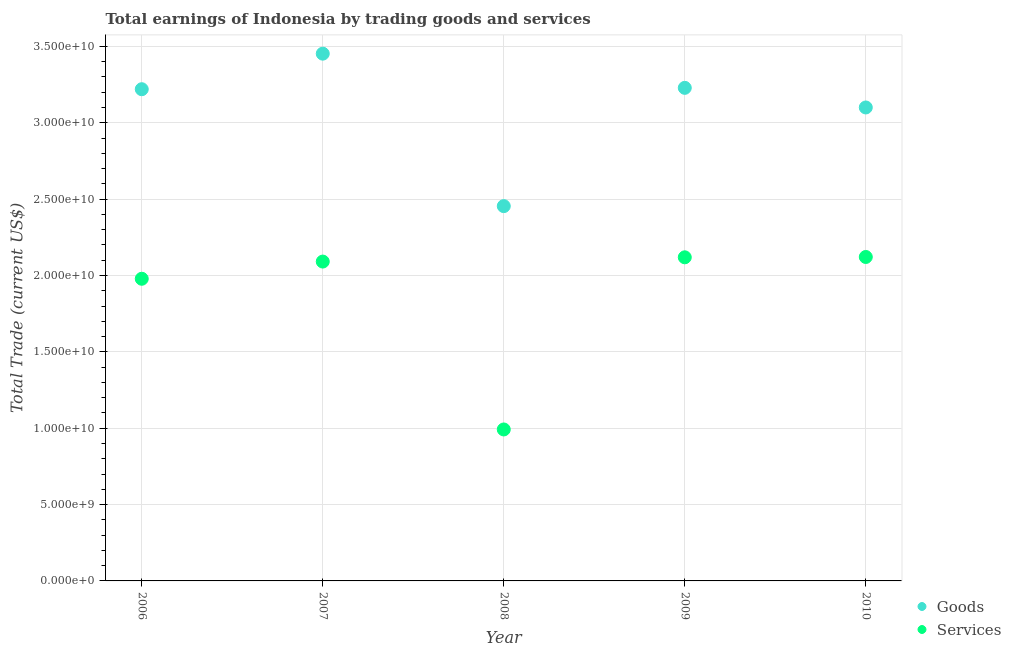How many different coloured dotlines are there?
Provide a short and direct response. 2. What is the amount earned by trading services in 2008?
Offer a very short reply. 9.92e+09. Across all years, what is the maximum amount earned by trading goods?
Give a very brief answer. 3.45e+1. Across all years, what is the minimum amount earned by trading goods?
Your answer should be very brief. 2.45e+1. In which year was the amount earned by trading services maximum?
Your answer should be very brief. 2010. In which year was the amount earned by trading services minimum?
Give a very brief answer. 2008. What is the total amount earned by trading goods in the graph?
Your response must be concise. 1.55e+11. What is the difference between the amount earned by trading goods in 2006 and that in 2008?
Your answer should be very brief. 7.66e+09. What is the difference between the amount earned by trading services in 2010 and the amount earned by trading goods in 2009?
Provide a succinct answer. -1.11e+1. What is the average amount earned by trading goods per year?
Your answer should be very brief. 3.09e+1. In the year 2009, what is the difference between the amount earned by trading services and amount earned by trading goods?
Provide a succinct answer. -1.11e+1. In how many years, is the amount earned by trading services greater than 31000000000 US$?
Provide a succinct answer. 0. What is the ratio of the amount earned by trading services in 2006 to that in 2008?
Provide a short and direct response. 2. What is the difference between the highest and the second highest amount earned by trading services?
Provide a succinct answer. 2.11e+07. What is the difference between the highest and the lowest amount earned by trading goods?
Ensure brevity in your answer.  9.98e+09. Does the amount earned by trading goods monotonically increase over the years?
Provide a short and direct response. No. Is the amount earned by trading goods strictly less than the amount earned by trading services over the years?
Make the answer very short. No. How many years are there in the graph?
Your answer should be compact. 5. Does the graph contain any zero values?
Provide a short and direct response. No. Does the graph contain grids?
Your answer should be very brief. Yes. How many legend labels are there?
Your response must be concise. 2. How are the legend labels stacked?
Provide a succinct answer. Vertical. What is the title of the graph?
Ensure brevity in your answer.  Total earnings of Indonesia by trading goods and services. Does "Forest" appear as one of the legend labels in the graph?
Your answer should be very brief. No. What is the label or title of the X-axis?
Give a very brief answer. Year. What is the label or title of the Y-axis?
Offer a terse response. Total Trade (current US$). What is the Total Trade (current US$) in Goods in 2006?
Make the answer very short. 3.22e+1. What is the Total Trade (current US$) of Services in 2006?
Your answer should be compact. 1.98e+1. What is the Total Trade (current US$) of Goods in 2007?
Offer a very short reply. 3.45e+1. What is the Total Trade (current US$) in Services in 2007?
Your response must be concise. 2.09e+1. What is the Total Trade (current US$) of Goods in 2008?
Provide a short and direct response. 2.45e+1. What is the Total Trade (current US$) of Services in 2008?
Ensure brevity in your answer.  9.92e+09. What is the Total Trade (current US$) of Goods in 2009?
Make the answer very short. 3.23e+1. What is the Total Trade (current US$) of Services in 2009?
Your response must be concise. 2.12e+1. What is the Total Trade (current US$) of Goods in 2010?
Your answer should be compact. 3.10e+1. What is the Total Trade (current US$) of Services in 2010?
Ensure brevity in your answer.  2.12e+1. Across all years, what is the maximum Total Trade (current US$) in Goods?
Ensure brevity in your answer.  3.45e+1. Across all years, what is the maximum Total Trade (current US$) in Services?
Make the answer very short. 2.12e+1. Across all years, what is the minimum Total Trade (current US$) in Goods?
Give a very brief answer. 2.45e+1. Across all years, what is the minimum Total Trade (current US$) in Services?
Give a very brief answer. 9.92e+09. What is the total Total Trade (current US$) in Goods in the graph?
Keep it short and to the point. 1.55e+11. What is the total Total Trade (current US$) of Services in the graph?
Provide a succinct answer. 9.30e+1. What is the difference between the Total Trade (current US$) of Goods in 2006 and that in 2007?
Offer a very short reply. -2.33e+09. What is the difference between the Total Trade (current US$) of Services in 2006 and that in 2007?
Provide a succinct answer. -1.13e+09. What is the difference between the Total Trade (current US$) in Goods in 2006 and that in 2008?
Provide a succinct answer. 7.66e+09. What is the difference between the Total Trade (current US$) in Services in 2006 and that in 2008?
Keep it short and to the point. 9.87e+09. What is the difference between the Total Trade (current US$) of Goods in 2006 and that in 2009?
Provide a short and direct response. -8.96e+07. What is the difference between the Total Trade (current US$) in Services in 2006 and that in 2009?
Give a very brief answer. -1.41e+09. What is the difference between the Total Trade (current US$) of Goods in 2006 and that in 2010?
Provide a short and direct response. 1.20e+09. What is the difference between the Total Trade (current US$) in Services in 2006 and that in 2010?
Give a very brief answer. -1.43e+09. What is the difference between the Total Trade (current US$) in Goods in 2007 and that in 2008?
Offer a very short reply. 9.98e+09. What is the difference between the Total Trade (current US$) of Services in 2007 and that in 2008?
Provide a succinct answer. 1.10e+1. What is the difference between the Total Trade (current US$) of Goods in 2007 and that in 2009?
Your answer should be compact. 2.24e+09. What is the difference between the Total Trade (current US$) of Services in 2007 and that in 2009?
Your response must be concise. -2.79e+08. What is the difference between the Total Trade (current US$) of Goods in 2007 and that in 2010?
Your answer should be very brief. 3.52e+09. What is the difference between the Total Trade (current US$) in Services in 2007 and that in 2010?
Offer a terse response. -3.00e+08. What is the difference between the Total Trade (current US$) in Goods in 2008 and that in 2009?
Your answer should be very brief. -7.75e+09. What is the difference between the Total Trade (current US$) in Services in 2008 and that in 2009?
Your response must be concise. -1.13e+1. What is the difference between the Total Trade (current US$) in Goods in 2008 and that in 2010?
Your answer should be compact. -6.46e+09. What is the difference between the Total Trade (current US$) of Services in 2008 and that in 2010?
Your answer should be very brief. -1.13e+1. What is the difference between the Total Trade (current US$) of Goods in 2009 and that in 2010?
Keep it short and to the point. 1.28e+09. What is the difference between the Total Trade (current US$) in Services in 2009 and that in 2010?
Give a very brief answer. -2.11e+07. What is the difference between the Total Trade (current US$) of Goods in 2006 and the Total Trade (current US$) of Services in 2007?
Your answer should be compact. 1.13e+1. What is the difference between the Total Trade (current US$) of Goods in 2006 and the Total Trade (current US$) of Services in 2008?
Provide a succinct answer. 2.23e+1. What is the difference between the Total Trade (current US$) of Goods in 2006 and the Total Trade (current US$) of Services in 2009?
Offer a terse response. 1.10e+1. What is the difference between the Total Trade (current US$) in Goods in 2006 and the Total Trade (current US$) in Services in 2010?
Keep it short and to the point. 1.10e+1. What is the difference between the Total Trade (current US$) of Goods in 2007 and the Total Trade (current US$) of Services in 2008?
Provide a succinct answer. 2.46e+1. What is the difference between the Total Trade (current US$) in Goods in 2007 and the Total Trade (current US$) in Services in 2009?
Your answer should be very brief. 1.33e+1. What is the difference between the Total Trade (current US$) of Goods in 2007 and the Total Trade (current US$) of Services in 2010?
Offer a very short reply. 1.33e+1. What is the difference between the Total Trade (current US$) of Goods in 2008 and the Total Trade (current US$) of Services in 2009?
Your answer should be compact. 3.35e+09. What is the difference between the Total Trade (current US$) in Goods in 2008 and the Total Trade (current US$) in Services in 2010?
Give a very brief answer. 3.33e+09. What is the difference between the Total Trade (current US$) of Goods in 2009 and the Total Trade (current US$) of Services in 2010?
Offer a very short reply. 1.11e+1. What is the average Total Trade (current US$) of Goods per year?
Keep it short and to the point. 3.09e+1. What is the average Total Trade (current US$) of Services per year?
Ensure brevity in your answer.  1.86e+1. In the year 2006, what is the difference between the Total Trade (current US$) in Goods and Total Trade (current US$) in Services?
Provide a short and direct response. 1.24e+1. In the year 2007, what is the difference between the Total Trade (current US$) of Goods and Total Trade (current US$) of Services?
Your answer should be very brief. 1.36e+1. In the year 2008, what is the difference between the Total Trade (current US$) of Goods and Total Trade (current US$) of Services?
Make the answer very short. 1.46e+1. In the year 2009, what is the difference between the Total Trade (current US$) in Goods and Total Trade (current US$) in Services?
Offer a very short reply. 1.11e+1. In the year 2010, what is the difference between the Total Trade (current US$) in Goods and Total Trade (current US$) in Services?
Your answer should be compact. 9.79e+09. What is the ratio of the Total Trade (current US$) in Goods in 2006 to that in 2007?
Your response must be concise. 0.93. What is the ratio of the Total Trade (current US$) of Services in 2006 to that in 2007?
Ensure brevity in your answer.  0.95. What is the ratio of the Total Trade (current US$) in Goods in 2006 to that in 2008?
Provide a succinct answer. 1.31. What is the ratio of the Total Trade (current US$) of Services in 2006 to that in 2008?
Offer a terse response. 2. What is the ratio of the Total Trade (current US$) of Services in 2006 to that in 2009?
Keep it short and to the point. 0.93. What is the ratio of the Total Trade (current US$) of Goods in 2006 to that in 2010?
Your response must be concise. 1.04. What is the ratio of the Total Trade (current US$) in Services in 2006 to that in 2010?
Keep it short and to the point. 0.93. What is the ratio of the Total Trade (current US$) of Goods in 2007 to that in 2008?
Offer a very short reply. 1.41. What is the ratio of the Total Trade (current US$) of Services in 2007 to that in 2008?
Offer a very short reply. 2.11. What is the ratio of the Total Trade (current US$) in Goods in 2007 to that in 2009?
Your answer should be compact. 1.07. What is the ratio of the Total Trade (current US$) in Goods in 2007 to that in 2010?
Keep it short and to the point. 1.11. What is the ratio of the Total Trade (current US$) in Services in 2007 to that in 2010?
Your response must be concise. 0.99. What is the ratio of the Total Trade (current US$) of Goods in 2008 to that in 2009?
Provide a succinct answer. 0.76. What is the ratio of the Total Trade (current US$) in Services in 2008 to that in 2009?
Your answer should be compact. 0.47. What is the ratio of the Total Trade (current US$) of Goods in 2008 to that in 2010?
Give a very brief answer. 0.79. What is the ratio of the Total Trade (current US$) of Services in 2008 to that in 2010?
Your response must be concise. 0.47. What is the ratio of the Total Trade (current US$) of Goods in 2009 to that in 2010?
Provide a short and direct response. 1.04. What is the difference between the highest and the second highest Total Trade (current US$) in Goods?
Keep it short and to the point. 2.24e+09. What is the difference between the highest and the second highest Total Trade (current US$) of Services?
Provide a succinct answer. 2.11e+07. What is the difference between the highest and the lowest Total Trade (current US$) of Goods?
Make the answer very short. 9.98e+09. What is the difference between the highest and the lowest Total Trade (current US$) of Services?
Offer a very short reply. 1.13e+1. 